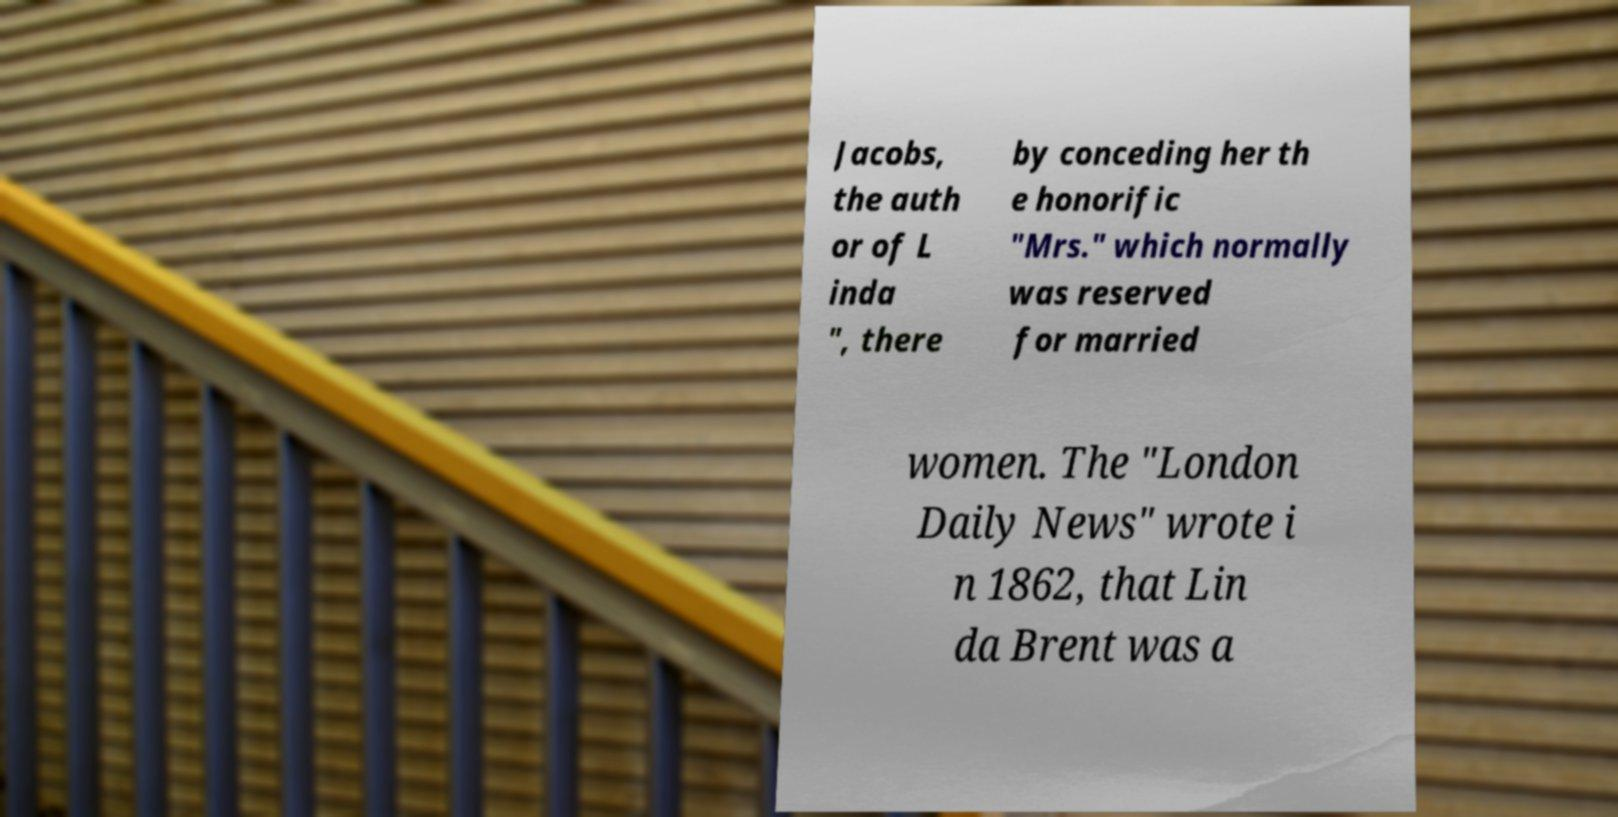What messages or text are displayed in this image? I need them in a readable, typed format. Jacobs, the auth or of L inda ", there by conceding her th e honorific "Mrs." which normally was reserved for married women. The "London Daily News" wrote i n 1862, that Lin da Brent was a 